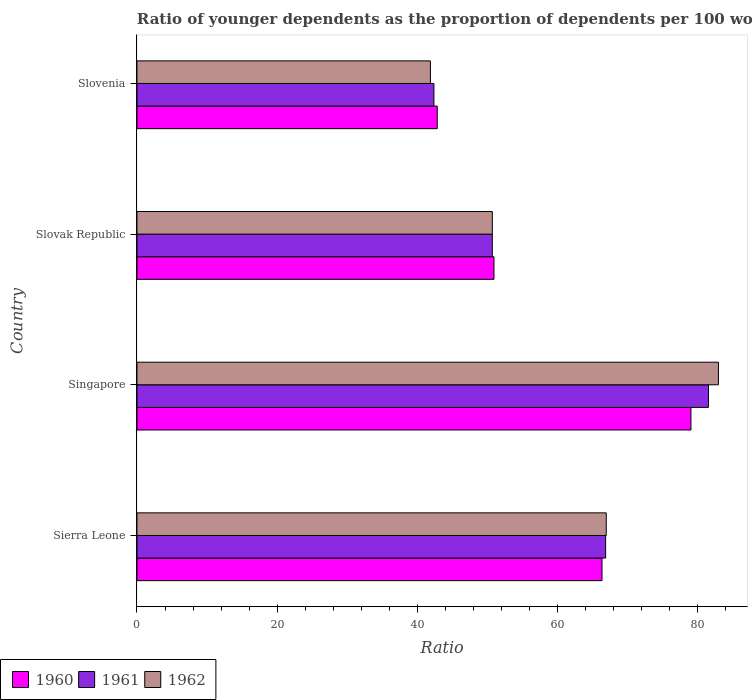How many groups of bars are there?
Provide a short and direct response. 4. How many bars are there on the 1st tick from the top?
Provide a succinct answer. 3. How many bars are there on the 3rd tick from the bottom?
Offer a terse response. 3. What is the label of the 4th group of bars from the top?
Your answer should be very brief. Sierra Leone. In how many cases, is the number of bars for a given country not equal to the number of legend labels?
Ensure brevity in your answer.  0. What is the age dependency ratio(young) in 1961 in Sierra Leone?
Your response must be concise. 66.87. Across all countries, what is the maximum age dependency ratio(young) in 1960?
Offer a terse response. 79.04. Across all countries, what is the minimum age dependency ratio(young) in 1961?
Offer a very short reply. 42.37. In which country was the age dependency ratio(young) in 1962 maximum?
Provide a succinct answer. Singapore. In which country was the age dependency ratio(young) in 1960 minimum?
Your response must be concise. Slovenia. What is the total age dependency ratio(young) in 1960 in the graph?
Provide a short and direct response. 239.18. What is the difference between the age dependency ratio(young) in 1961 in Sierra Leone and that in Slovak Republic?
Offer a terse response. 16.17. What is the difference between the age dependency ratio(young) in 1960 in Sierra Leone and the age dependency ratio(young) in 1962 in Slovenia?
Offer a terse response. 24.48. What is the average age dependency ratio(young) in 1962 per country?
Your answer should be very brief. 60.62. What is the difference between the age dependency ratio(young) in 1960 and age dependency ratio(young) in 1962 in Singapore?
Offer a terse response. -3.92. In how many countries, is the age dependency ratio(young) in 1960 greater than 52 ?
Your answer should be compact. 2. What is the ratio of the age dependency ratio(young) in 1960 in Singapore to that in Slovak Republic?
Offer a very short reply. 1.55. What is the difference between the highest and the second highest age dependency ratio(young) in 1961?
Provide a short and direct response. 14.67. What is the difference between the highest and the lowest age dependency ratio(young) in 1962?
Offer a terse response. 41.09. In how many countries, is the age dependency ratio(young) in 1961 greater than the average age dependency ratio(young) in 1961 taken over all countries?
Ensure brevity in your answer.  2. Is the sum of the age dependency ratio(young) in 1961 in Singapore and Slovak Republic greater than the maximum age dependency ratio(young) in 1960 across all countries?
Give a very brief answer. Yes. What does the 3rd bar from the top in Singapore represents?
Offer a very short reply. 1960. How many bars are there?
Your response must be concise. 12. How many countries are there in the graph?
Give a very brief answer. 4. What is the difference between two consecutive major ticks on the X-axis?
Your answer should be very brief. 20. Are the values on the major ticks of X-axis written in scientific E-notation?
Provide a short and direct response. No. Does the graph contain any zero values?
Provide a succinct answer. No. Where does the legend appear in the graph?
Provide a succinct answer. Bottom left. How are the legend labels stacked?
Offer a very short reply. Horizontal. What is the title of the graph?
Your response must be concise. Ratio of younger dependents as the proportion of dependents per 100 working-age population. Does "1972" appear as one of the legend labels in the graph?
Provide a short and direct response. No. What is the label or title of the X-axis?
Give a very brief answer. Ratio. What is the label or title of the Y-axis?
Your answer should be very brief. Country. What is the Ratio in 1960 in Sierra Leone?
Keep it short and to the point. 66.35. What is the Ratio of 1961 in Sierra Leone?
Offer a terse response. 66.87. What is the Ratio in 1962 in Sierra Leone?
Provide a succinct answer. 66.96. What is the Ratio in 1960 in Singapore?
Make the answer very short. 79.04. What is the Ratio in 1961 in Singapore?
Your answer should be compact. 81.54. What is the Ratio of 1962 in Singapore?
Your answer should be compact. 82.96. What is the Ratio in 1960 in Slovak Republic?
Provide a short and direct response. 50.94. What is the Ratio in 1961 in Slovak Republic?
Ensure brevity in your answer.  50.7. What is the Ratio of 1962 in Slovak Republic?
Keep it short and to the point. 50.71. What is the Ratio of 1960 in Slovenia?
Keep it short and to the point. 42.85. What is the Ratio in 1961 in Slovenia?
Your response must be concise. 42.37. What is the Ratio in 1962 in Slovenia?
Give a very brief answer. 41.87. Across all countries, what is the maximum Ratio of 1960?
Keep it short and to the point. 79.04. Across all countries, what is the maximum Ratio of 1961?
Offer a very short reply. 81.54. Across all countries, what is the maximum Ratio in 1962?
Make the answer very short. 82.96. Across all countries, what is the minimum Ratio of 1960?
Make the answer very short. 42.85. Across all countries, what is the minimum Ratio of 1961?
Make the answer very short. 42.37. Across all countries, what is the minimum Ratio in 1962?
Your answer should be compact. 41.87. What is the total Ratio in 1960 in the graph?
Your answer should be very brief. 239.18. What is the total Ratio in 1961 in the graph?
Offer a very short reply. 241.49. What is the total Ratio of 1962 in the graph?
Keep it short and to the point. 242.5. What is the difference between the Ratio in 1960 in Sierra Leone and that in Singapore?
Your answer should be compact. -12.69. What is the difference between the Ratio of 1961 in Sierra Leone and that in Singapore?
Make the answer very short. -14.67. What is the difference between the Ratio of 1962 in Sierra Leone and that in Singapore?
Make the answer very short. -16.01. What is the difference between the Ratio of 1960 in Sierra Leone and that in Slovak Republic?
Offer a terse response. 15.41. What is the difference between the Ratio in 1961 in Sierra Leone and that in Slovak Republic?
Ensure brevity in your answer.  16.17. What is the difference between the Ratio in 1962 in Sierra Leone and that in Slovak Republic?
Make the answer very short. 16.25. What is the difference between the Ratio in 1960 in Sierra Leone and that in Slovenia?
Offer a terse response. 23.51. What is the difference between the Ratio in 1961 in Sierra Leone and that in Slovenia?
Your answer should be very brief. 24.5. What is the difference between the Ratio of 1962 in Sierra Leone and that in Slovenia?
Your answer should be compact. 25.09. What is the difference between the Ratio of 1960 in Singapore and that in Slovak Republic?
Your answer should be compact. 28.1. What is the difference between the Ratio of 1961 in Singapore and that in Slovak Republic?
Offer a very short reply. 30.84. What is the difference between the Ratio of 1962 in Singapore and that in Slovak Republic?
Your response must be concise. 32.26. What is the difference between the Ratio in 1960 in Singapore and that in Slovenia?
Your response must be concise. 36.2. What is the difference between the Ratio in 1961 in Singapore and that in Slovenia?
Provide a succinct answer. 39.17. What is the difference between the Ratio in 1962 in Singapore and that in Slovenia?
Make the answer very short. 41.09. What is the difference between the Ratio of 1960 in Slovak Republic and that in Slovenia?
Your answer should be compact. 8.09. What is the difference between the Ratio in 1961 in Slovak Republic and that in Slovenia?
Ensure brevity in your answer.  8.33. What is the difference between the Ratio in 1962 in Slovak Republic and that in Slovenia?
Your answer should be compact. 8.84. What is the difference between the Ratio of 1960 in Sierra Leone and the Ratio of 1961 in Singapore?
Offer a very short reply. -15.19. What is the difference between the Ratio in 1960 in Sierra Leone and the Ratio in 1962 in Singapore?
Give a very brief answer. -16.61. What is the difference between the Ratio of 1961 in Sierra Leone and the Ratio of 1962 in Singapore?
Ensure brevity in your answer.  -16.09. What is the difference between the Ratio in 1960 in Sierra Leone and the Ratio in 1961 in Slovak Republic?
Your answer should be compact. 15.65. What is the difference between the Ratio of 1960 in Sierra Leone and the Ratio of 1962 in Slovak Republic?
Offer a terse response. 15.65. What is the difference between the Ratio in 1961 in Sierra Leone and the Ratio in 1962 in Slovak Republic?
Offer a terse response. 16.17. What is the difference between the Ratio of 1960 in Sierra Leone and the Ratio of 1961 in Slovenia?
Your answer should be very brief. 23.98. What is the difference between the Ratio in 1960 in Sierra Leone and the Ratio in 1962 in Slovenia?
Give a very brief answer. 24.48. What is the difference between the Ratio in 1961 in Sierra Leone and the Ratio in 1962 in Slovenia?
Ensure brevity in your answer.  25. What is the difference between the Ratio in 1960 in Singapore and the Ratio in 1961 in Slovak Republic?
Give a very brief answer. 28.34. What is the difference between the Ratio in 1960 in Singapore and the Ratio in 1962 in Slovak Republic?
Ensure brevity in your answer.  28.34. What is the difference between the Ratio in 1961 in Singapore and the Ratio in 1962 in Slovak Republic?
Keep it short and to the point. 30.84. What is the difference between the Ratio in 1960 in Singapore and the Ratio in 1961 in Slovenia?
Offer a terse response. 36.67. What is the difference between the Ratio in 1960 in Singapore and the Ratio in 1962 in Slovenia?
Your response must be concise. 37.17. What is the difference between the Ratio in 1961 in Singapore and the Ratio in 1962 in Slovenia?
Offer a very short reply. 39.67. What is the difference between the Ratio of 1960 in Slovak Republic and the Ratio of 1961 in Slovenia?
Give a very brief answer. 8.57. What is the difference between the Ratio of 1960 in Slovak Republic and the Ratio of 1962 in Slovenia?
Provide a succinct answer. 9.07. What is the difference between the Ratio of 1961 in Slovak Republic and the Ratio of 1962 in Slovenia?
Ensure brevity in your answer.  8.83. What is the average Ratio in 1960 per country?
Give a very brief answer. 59.8. What is the average Ratio of 1961 per country?
Give a very brief answer. 60.37. What is the average Ratio in 1962 per country?
Offer a terse response. 60.62. What is the difference between the Ratio in 1960 and Ratio in 1961 in Sierra Leone?
Offer a very short reply. -0.52. What is the difference between the Ratio of 1960 and Ratio of 1962 in Sierra Leone?
Provide a succinct answer. -0.61. What is the difference between the Ratio in 1961 and Ratio in 1962 in Sierra Leone?
Provide a short and direct response. -0.09. What is the difference between the Ratio in 1960 and Ratio in 1961 in Singapore?
Your answer should be very brief. -2.5. What is the difference between the Ratio in 1960 and Ratio in 1962 in Singapore?
Ensure brevity in your answer.  -3.92. What is the difference between the Ratio of 1961 and Ratio of 1962 in Singapore?
Make the answer very short. -1.42. What is the difference between the Ratio of 1960 and Ratio of 1961 in Slovak Republic?
Ensure brevity in your answer.  0.24. What is the difference between the Ratio in 1960 and Ratio in 1962 in Slovak Republic?
Provide a short and direct response. 0.23. What is the difference between the Ratio in 1961 and Ratio in 1962 in Slovak Republic?
Your answer should be compact. -0.01. What is the difference between the Ratio in 1960 and Ratio in 1961 in Slovenia?
Provide a succinct answer. 0.48. What is the difference between the Ratio in 1960 and Ratio in 1962 in Slovenia?
Your answer should be compact. 0.98. What is the difference between the Ratio of 1961 and Ratio of 1962 in Slovenia?
Offer a terse response. 0.5. What is the ratio of the Ratio in 1960 in Sierra Leone to that in Singapore?
Offer a very short reply. 0.84. What is the ratio of the Ratio of 1961 in Sierra Leone to that in Singapore?
Your answer should be very brief. 0.82. What is the ratio of the Ratio of 1962 in Sierra Leone to that in Singapore?
Ensure brevity in your answer.  0.81. What is the ratio of the Ratio of 1960 in Sierra Leone to that in Slovak Republic?
Offer a terse response. 1.3. What is the ratio of the Ratio in 1961 in Sierra Leone to that in Slovak Republic?
Offer a very short reply. 1.32. What is the ratio of the Ratio of 1962 in Sierra Leone to that in Slovak Republic?
Keep it short and to the point. 1.32. What is the ratio of the Ratio in 1960 in Sierra Leone to that in Slovenia?
Your answer should be very brief. 1.55. What is the ratio of the Ratio of 1961 in Sierra Leone to that in Slovenia?
Your answer should be compact. 1.58. What is the ratio of the Ratio in 1962 in Sierra Leone to that in Slovenia?
Offer a very short reply. 1.6. What is the ratio of the Ratio in 1960 in Singapore to that in Slovak Republic?
Offer a terse response. 1.55. What is the ratio of the Ratio in 1961 in Singapore to that in Slovak Republic?
Make the answer very short. 1.61. What is the ratio of the Ratio of 1962 in Singapore to that in Slovak Republic?
Give a very brief answer. 1.64. What is the ratio of the Ratio of 1960 in Singapore to that in Slovenia?
Make the answer very short. 1.84. What is the ratio of the Ratio in 1961 in Singapore to that in Slovenia?
Your response must be concise. 1.92. What is the ratio of the Ratio in 1962 in Singapore to that in Slovenia?
Your response must be concise. 1.98. What is the ratio of the Ratio of 1960 in Slovak Republic to that in Slovenia?
Keep it short and to the point. 1.19. What is the ratio of the Ratio in 1961 in Slovak Republic to that in Slovenia?
Offer a very short reply. 1.2. What is the ratio of the Ratio in 1962 in Slovak Republic to that in Slovenia?
Offer a terse response. 1.21. What is the difference between the highest and the second highest Ratio of 1960?
Make the answer very short. 12.69. What is the difference between the highest and the second highest Ratio in 1961?
Offer a very short reply. 14.67. What is the difference between the highest and the second highest Ratio of 1962?
Make the answer very short. 16.01. What is the difference between the highest and the lowest Ratio of 1960?
Make the answer very short. 36.2. What is the difference between the highest and the lowest Ratio in 1961?
Provide a succinct answer. 39.17. What is the difference between the highest and the lowest Ratio in 1962?
Make the answer very short. 41.09. 